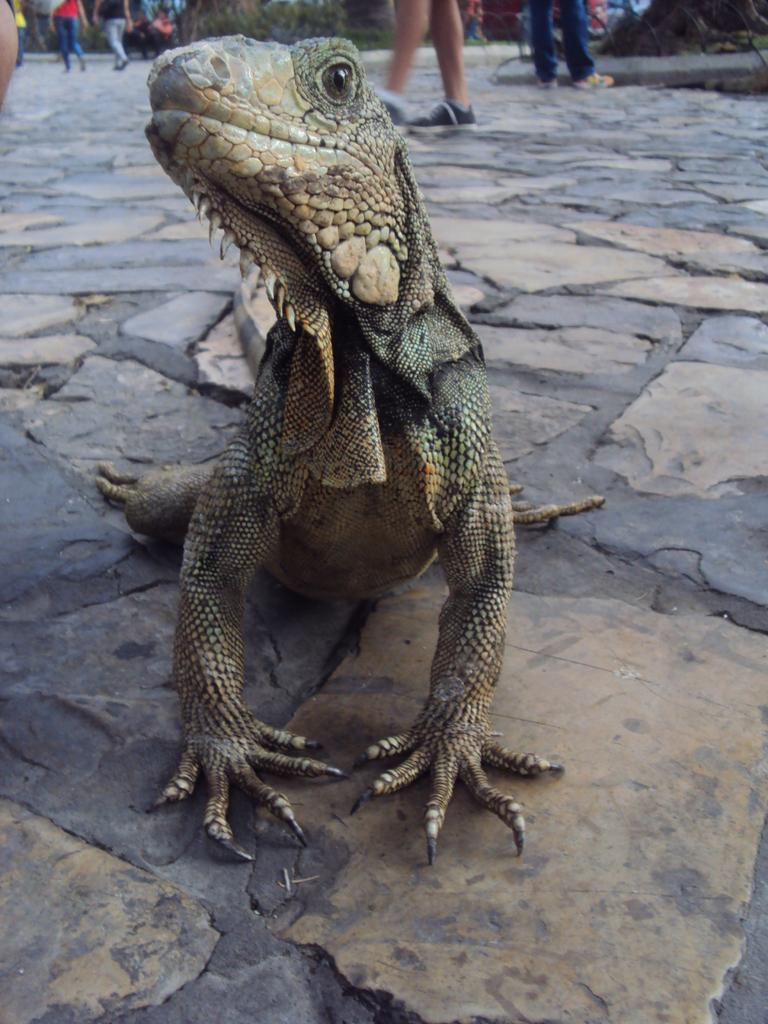What type of animal is on the surface in the image? The specific type of animal cannot be determined from the provided facts. What are the people in the background of the image doing? The people in the background are walking and standing. What type of vegetation is present in the image? There are plants and trees in the image. What type of comfort can be seen in the image? There is no reference to comfort in the image, as it features an animal, people, plants, and trees. What type of town is visible in the image? There is no town present in the image. 